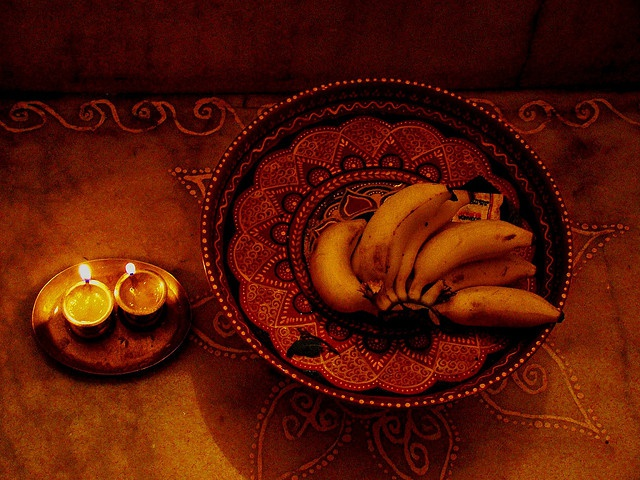Describe the objects in this image and their specific colors. I can see bowl in black, maroon, and red tones and banana in black, maroon, and red tones in this image. 